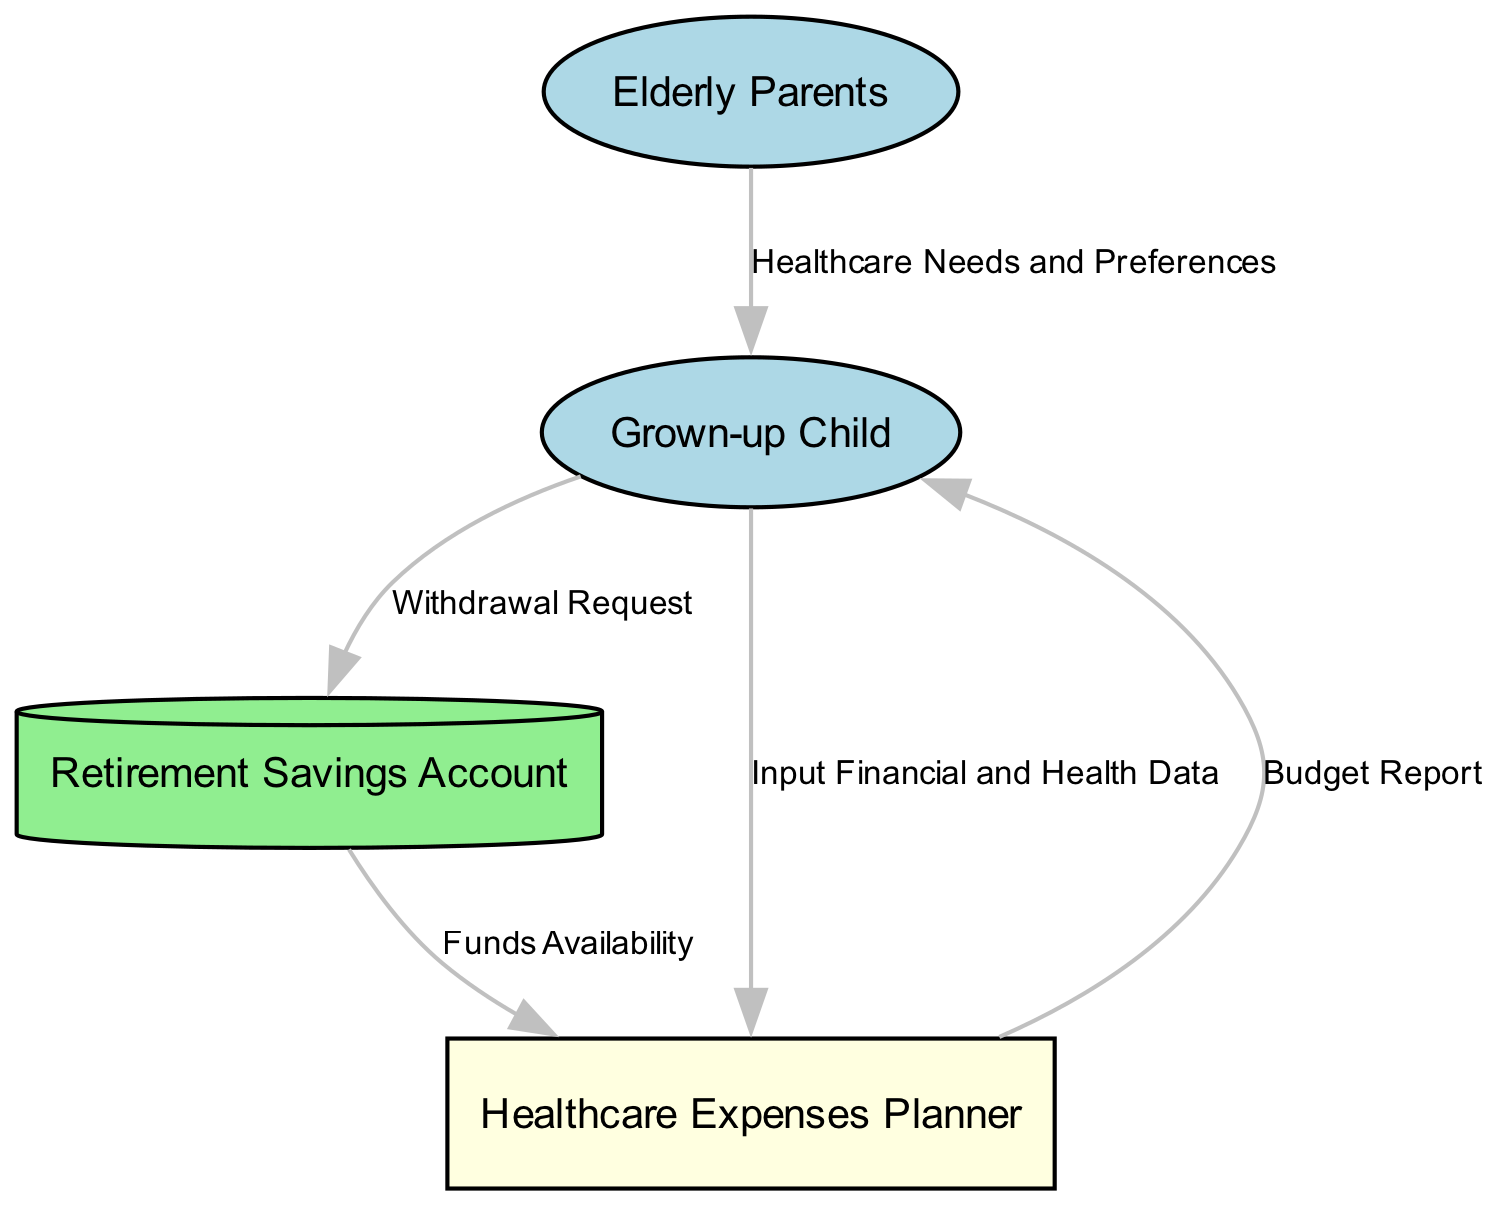What are the external entities in the diagram? The diagram has two external entities, "Elderly Parents" and "Grown-up Child." These are the sources of input and receivers of output in the data flow.
Answer: Elderly Parents, Grown-up Child How many data flows are present in the diagram? The diagram consists of five distinct data flows, each showing the movement of information between nodes.
Answer: 5 What does the "Healthcare Needs and Preferences" flow represent? This flow moves from "Elderly Parents" to "Grown-up Child" and represents the information about the healthcare requirements and preferences that the elderly parents communicate.
Answer: Healthcare Needs and Preferences Which process is responsible for generating the "Budget Report"? The "Healthcare Expenses Planner" process takes inputs related to financial and health data and funds availability to produce the budget report.
Answer: Healthcare Expenses Planner From which node does the "Withdrawal Request" originate? The "Withdrawal Request" is initiated by the "Grown-up Child" and sent to the "Retirement Savings Account" as a request for funds.
Answer: Grown-up Child What type of data store is represented in this diagram? The "Retirement Savings Account" is a data store that holds financial resources and is depicted as a cylinder shape to indicate its function of storing data.
Answer: Data Store What input data does the "Healthcare Expenses Planner" require? The process requires two inputs: "Input Financial and Health Data" and "Funds Availability" to function effectively and produce a budget report.
Answer: Input Financial and Health Data, Funds Availability What is the output of the "Healthcare Expenses Planner"? The output of the "Healthcare Expenses Planner" is the "Budget Report," which summarizes the planned healthcare expenses based on the input data.
Answer: Budget Report How does the "Grown-up Child" interact with the "Retirement Savings Account"? The "Grown-up Child" interacts with the "Retirement Savings Account" by sending a "Withdrawal Request" to access funds when needed for healthcare expenses.
Answer: Withdrawal Request Which node provides information about the availability of funds? The "Retirement Savings Account" provides data concerning "Funds Availability" that is then utilized by the "Healthcare Expenses Planner" in its calculations.
Answer: Retirement Savings Account 